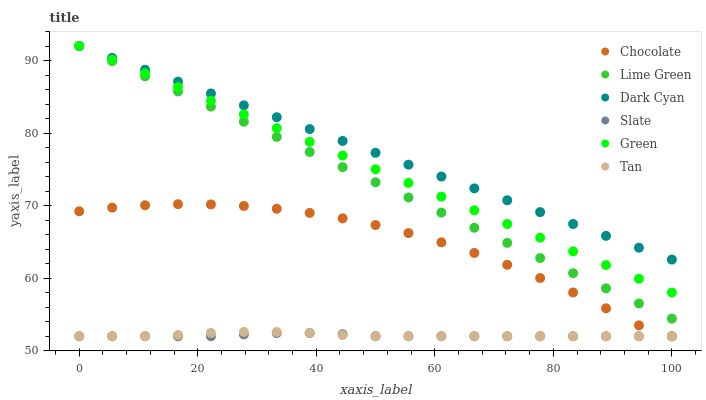Does Slate have the minimum area under the curve?
Answer yes or no. Yes. Does Dark Cyan have the maximum area under the curve?
Answer yes or no. Yes. Does Chocolate have the minimum area under the curve?
Answer yes or no. No. Does Chocolate have the maximum area under the curve?
Answer yes or no. No. Is Dark Cyan the smoothest?
Answer yes or no. Yes. Is Chocolate the roughest?
Answer yes or no. Yes. Is Green the smoothest?
Answer yes or no. No. Is Green the roughest?
Answer yes or no. No. Does Slate have the lowest value?
Answer yes or no. Yes. Does Green have the lowest value?
Answer yes or no. No. Does Lime Green have the highest value?
Answer yes or no. Yes. Does Chocolate have the highest value?
Answer yes or no. No. Is Slate less than Dark Cyan?
Answer yes or no. Yes. Is Green greater than Chocolate?
Answer yes or no. Yes. Does Tan intersect Slate?
Answer yes or no. Yes. Is Tan less than Slate?
Answer yes or no. No. Is Tan greater than Slate?
Answer yes or no. No. Does Slate intersect Dark Cyan?
Answer yes or no. No. 